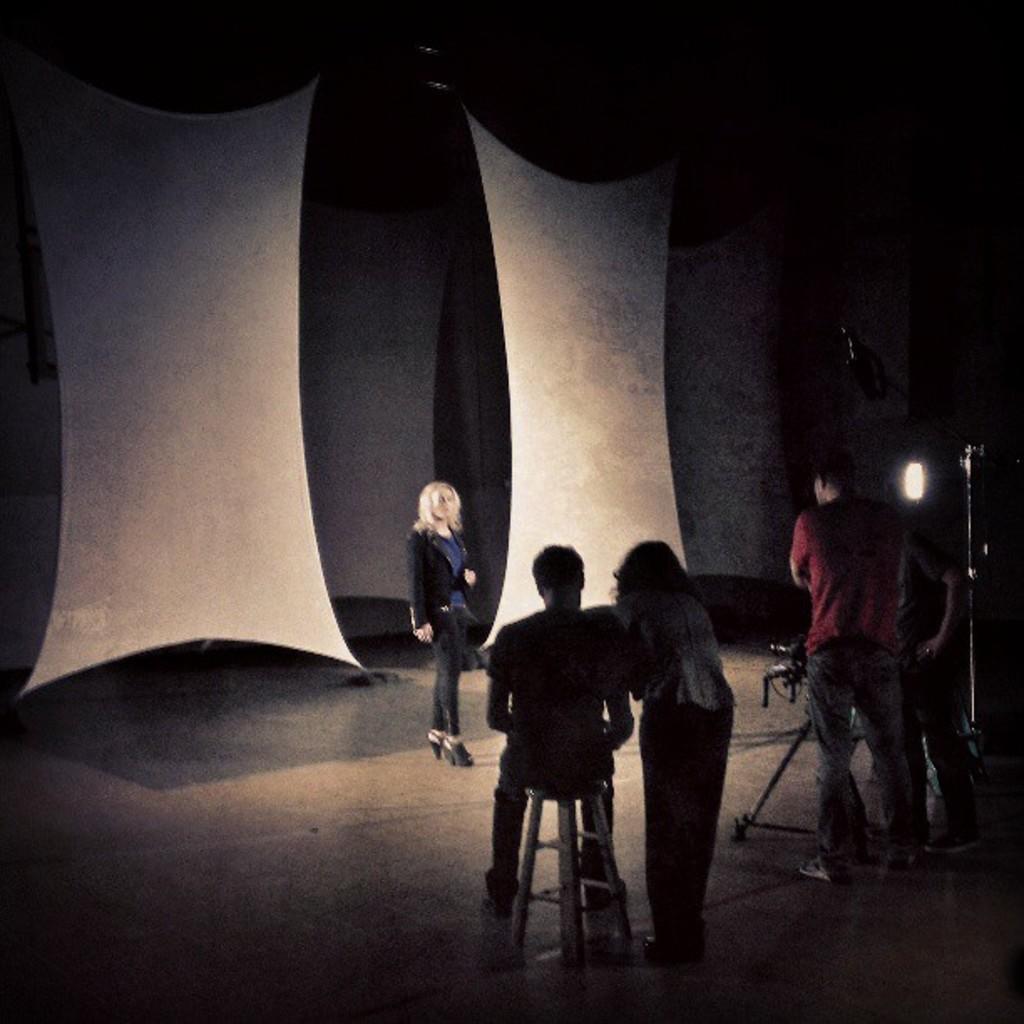How would you summarize this image in a sentence or two? In this picture we can observe some people. There are two white color clothes behind the woman. We can observe men and women in this picture. On the right side there is white color light. The background is completely dark. 